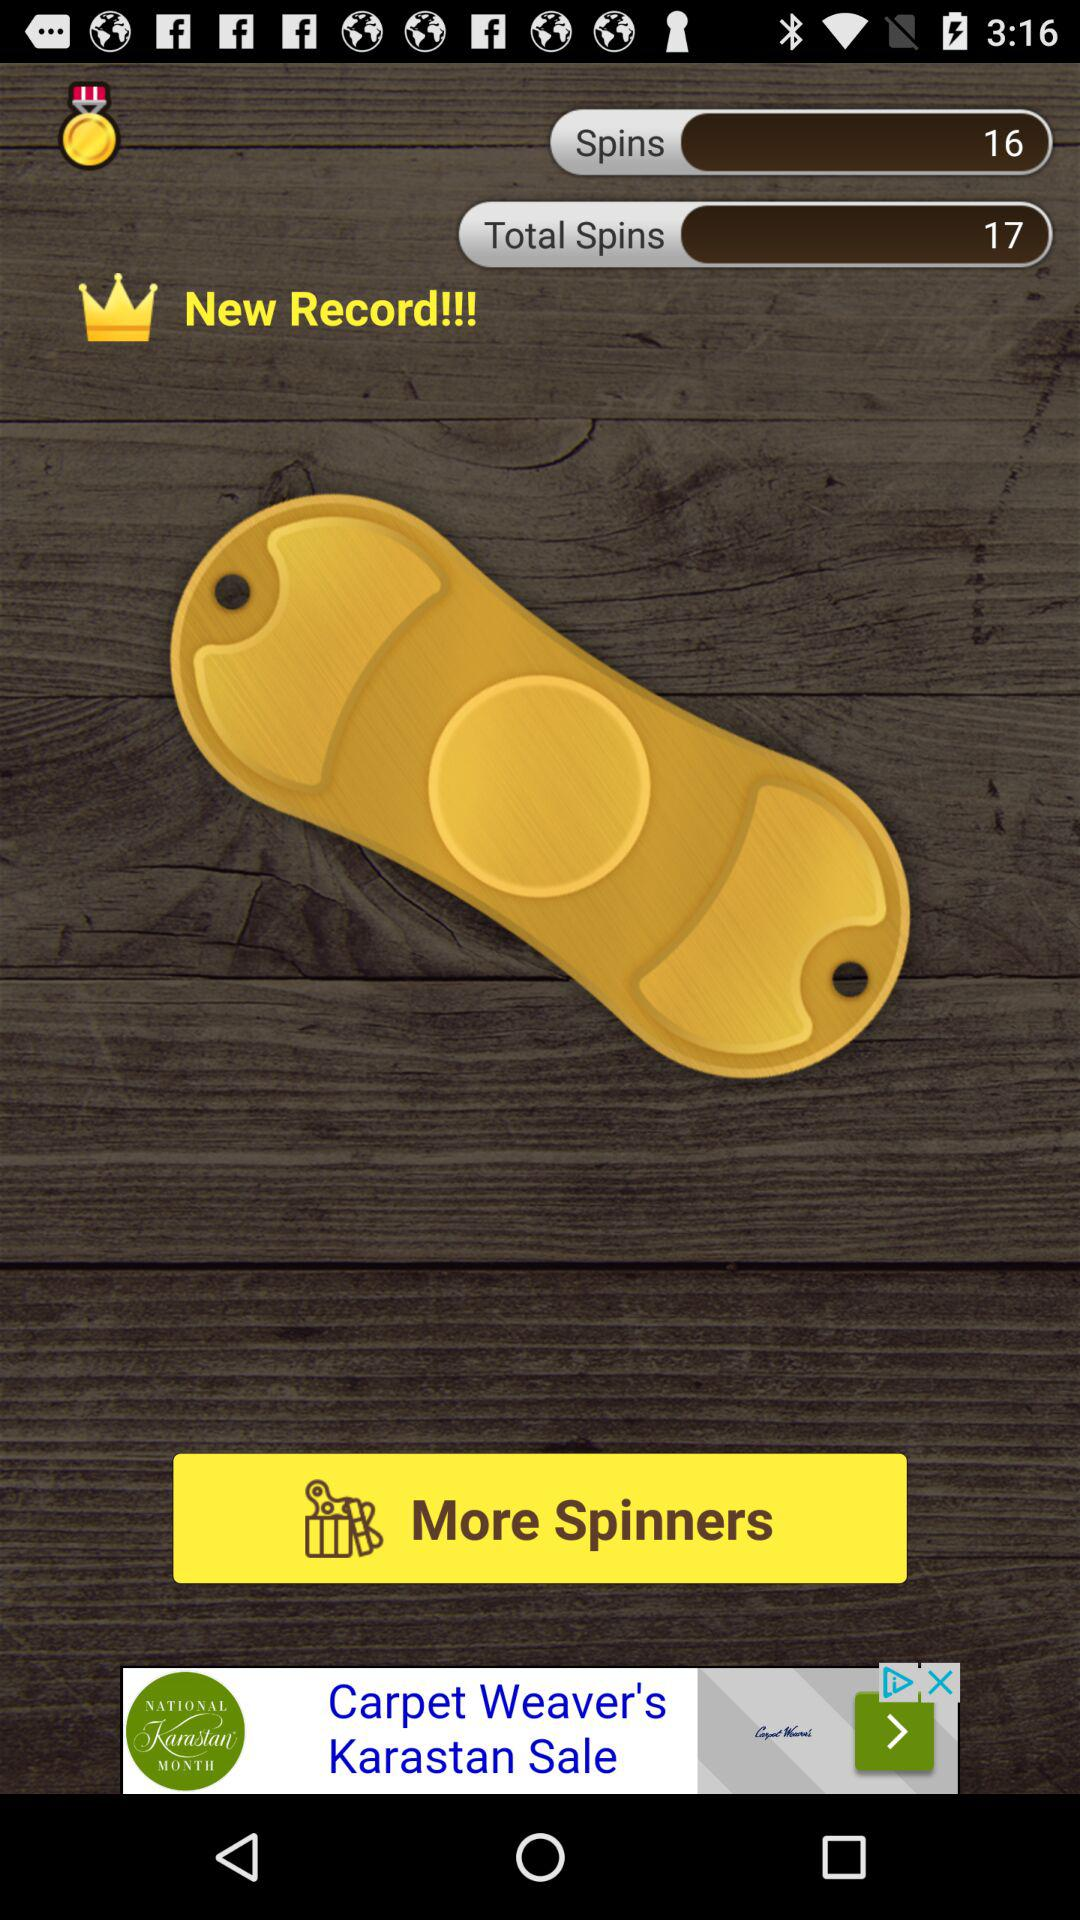How many total spins are there? There are a total of 17 spins. 